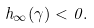<formula> <loc_0><loc_0><loc_500><loc_500>h _ { \infty } ( \gamma ) < 0 .</formula> 